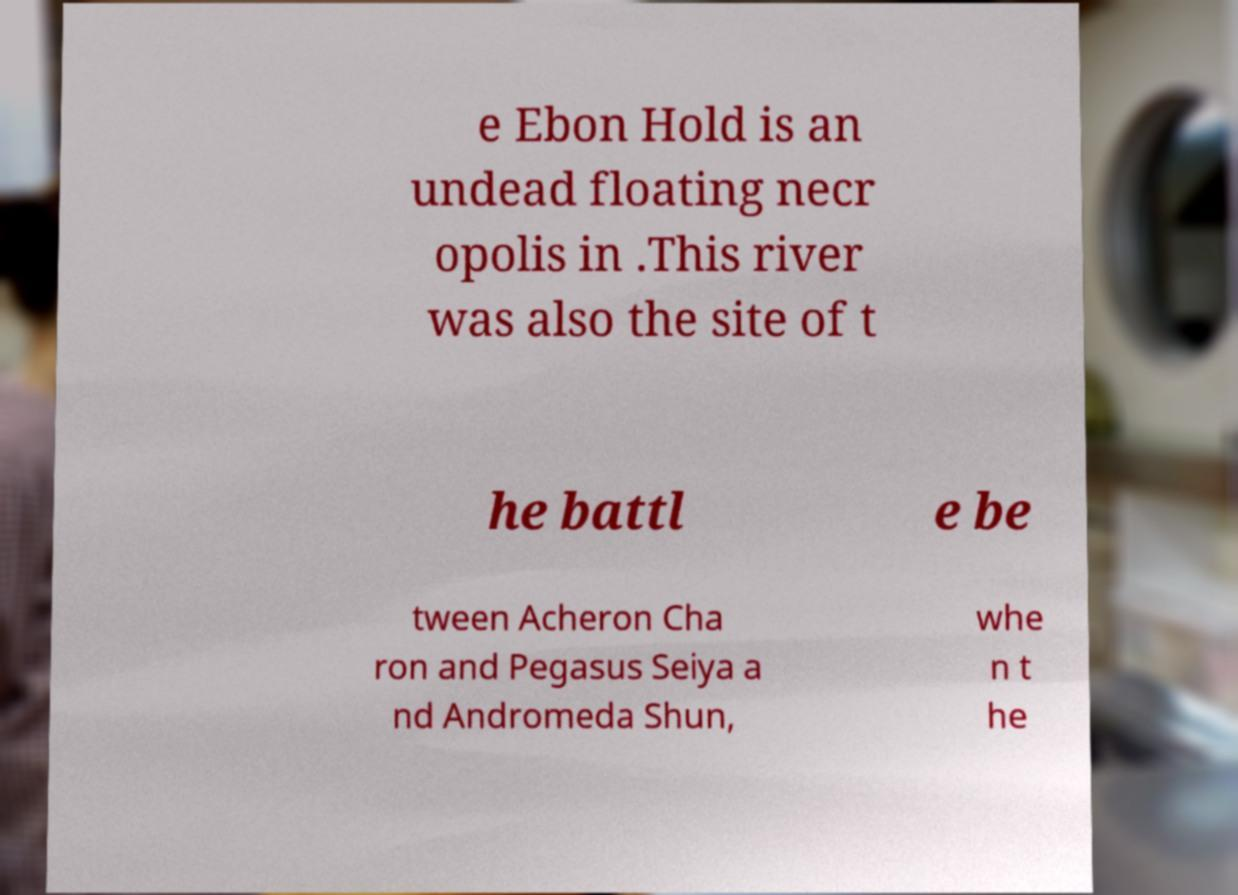There's text embedded in this image that I need extracted. Can you transcribe it verbatim? e Ebon Hold is an undead floating necr opolis in .This river was also the site of t he battl e be tween Acheron Cha ron and Pegasus Seiya a nd Andromeda Shun, whe n t he 